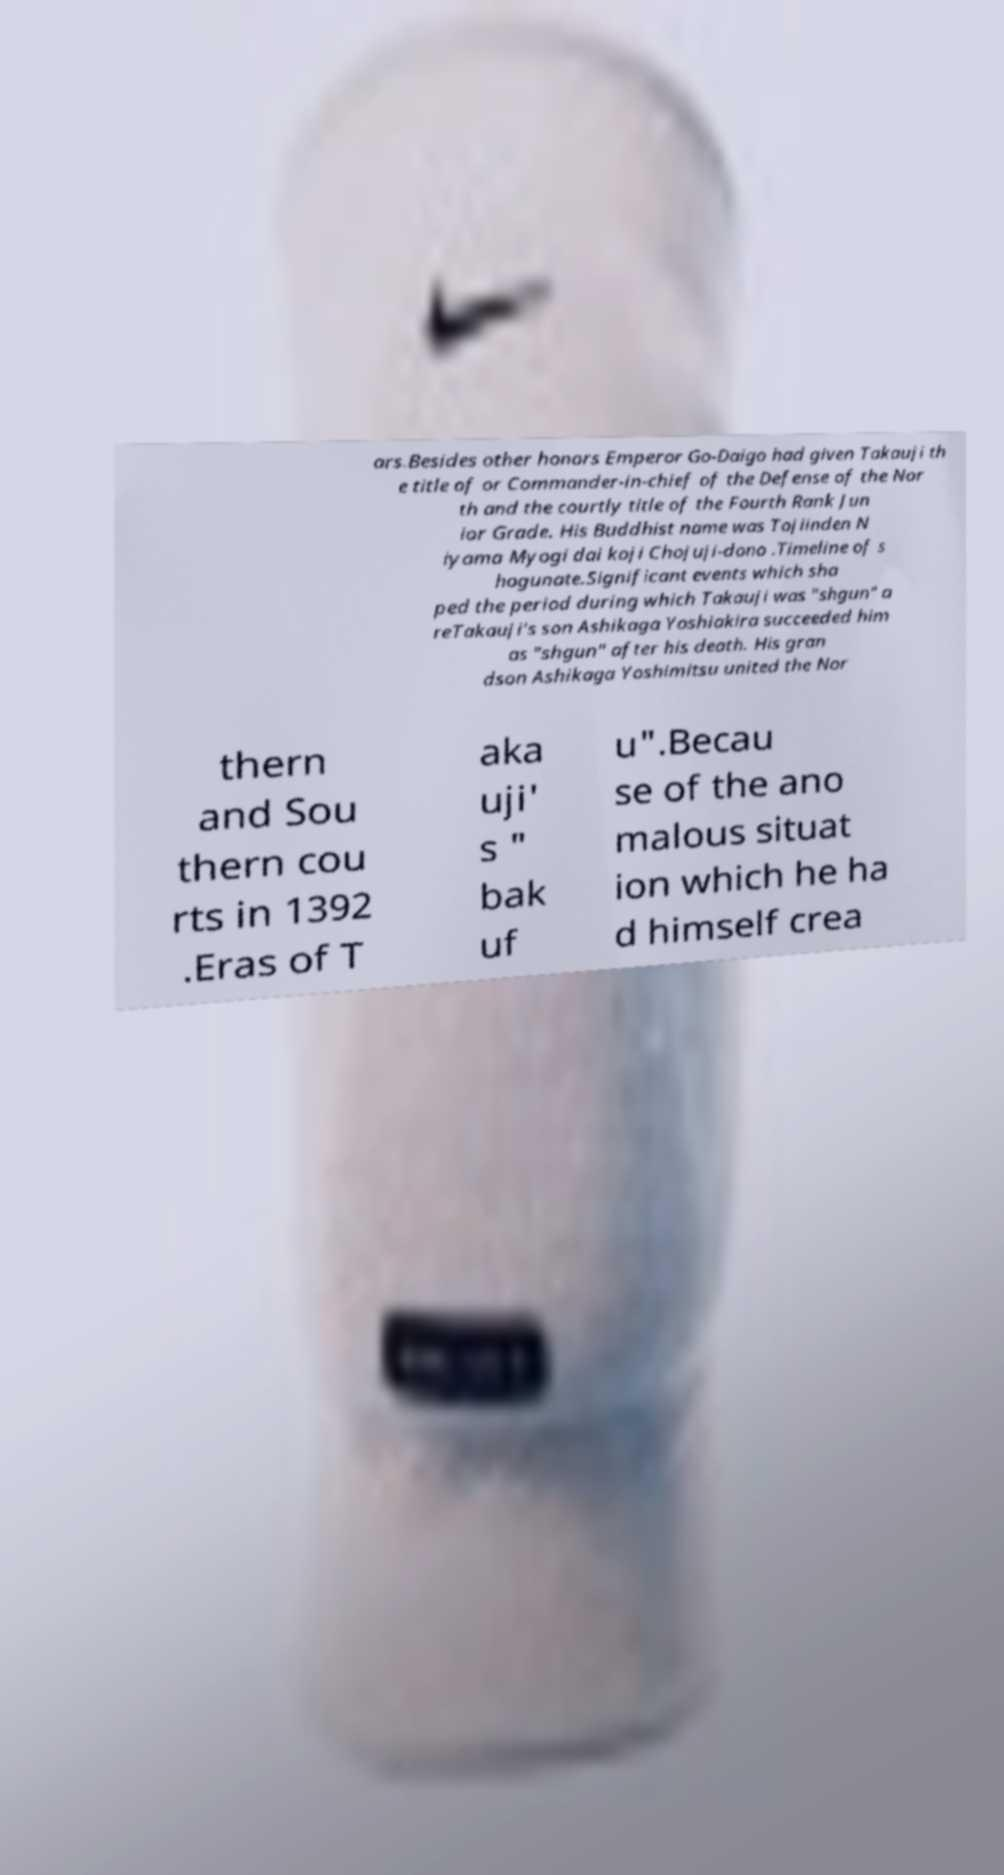What messages or text are displayed in this image? I need them in a readable, typed format. ars.Besides other honors Emperor Go-Daigo had given Takauji th e title of or Commander-in-chief of the Defense of the Nor th and the courtly title of the Fourth Rank Jun ior Grade. His Buddhist name was Tojiinden N iyama Myogi dai koji Chojuji-dono .Timeline of s hogunate.Significant events which sha ped the period during which Takauji was "shgun" a reTakauji's son Ashikaga Yoshiakira succeeded him as "shgun" after his death. His gran dson Ashikaga Yoshimitsu united the Nor thern and Sou thern cou rts in 1392 .Eras of T aka uji' s " bak uf u".Becau se of the ano malous situat ion which he ha d himself crea 